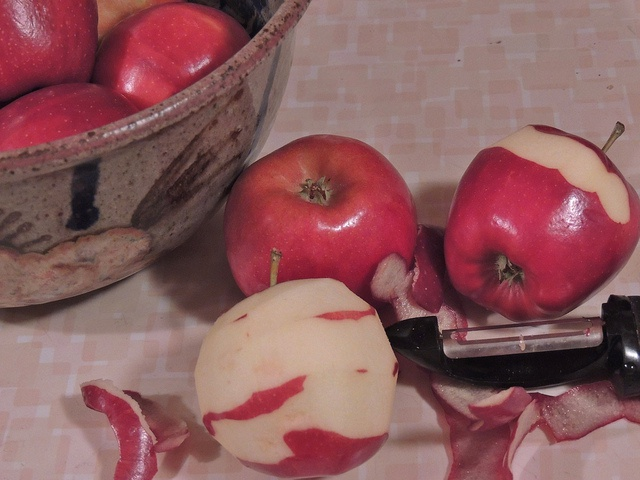Describe the objects in this image and their specific colors. I can see dining table in brown, gray, and maroon tones, bowl in brown, gray, maroon, and black tones, apple in brown and tan tones, apple in brown, maroon, and tan tones, and apple in brown and maroon tones in this image. 